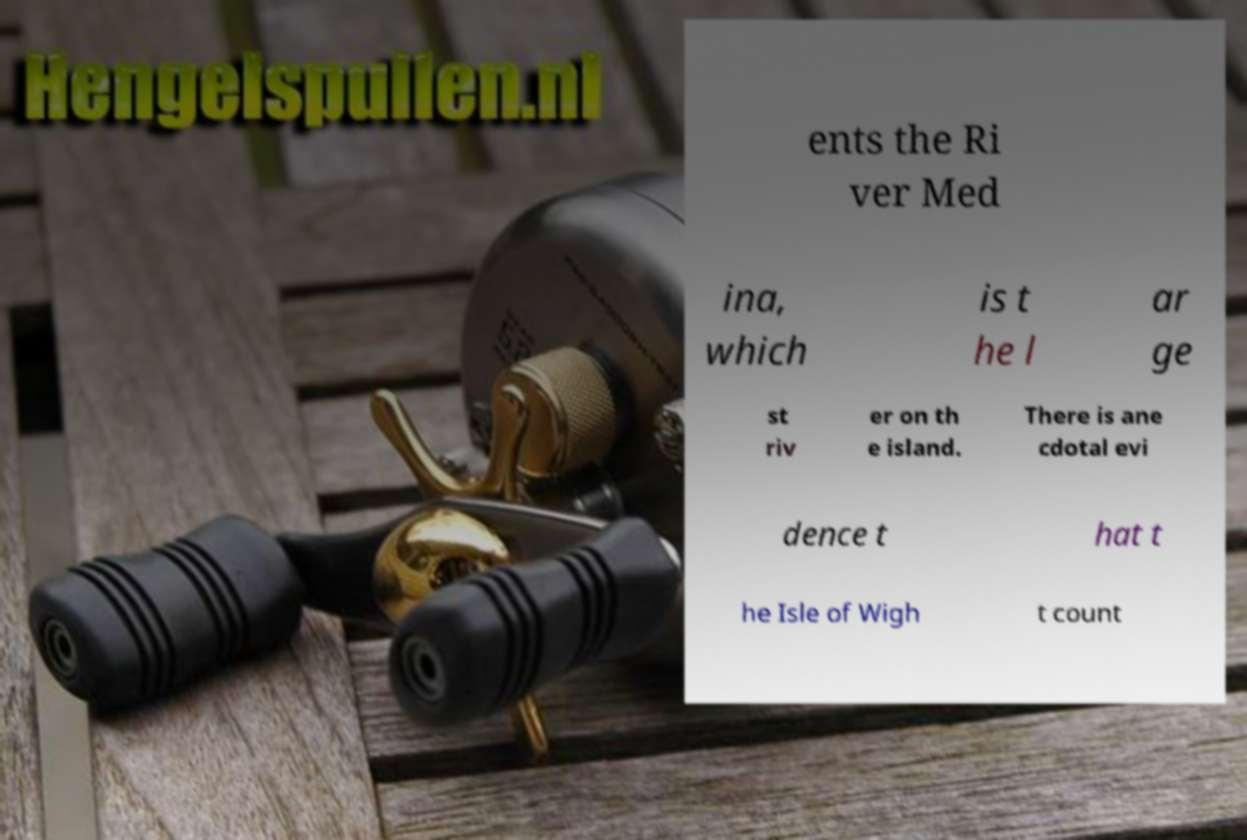Please identify and transcribe the text found in this image. ents the Ri ver Med ina, which is t he l ar ge st riv er on th e island. There is ane cdotal evi dence t hat t he Isle of Wigh t count 